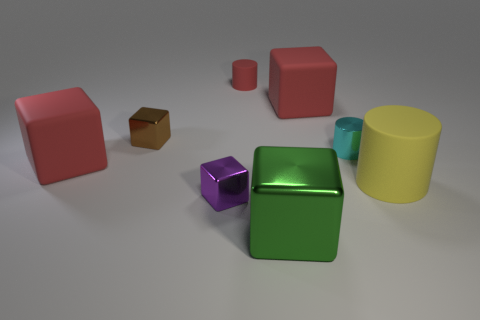The red rubber cylinder has what size?
Your response must be concise. Small. There is a big red cube that is on the right side of the red matte block that is to the left of the tiny purple metallic thing; how many tiny objects are right of it?
Your response must be concise. 1. There is a rubber object in front of the rubber cube on the left side of the tiny red object; what is its shape?
Make the answer very short. Cylinder. The green metallic thing that is the same shape as the brown shiny object is what size?
Ensure brevity in your answer.  Large. Is there any other thing that has the same size as the green metal object?
Offer a very short reply. Yes. There is a cylinder in front of the cyan shiny cylinder; what is its color?
Make the answer very short. Yellow. The small object that is right of the big block that is behind the red rubber block left of the purple metal cube is made of what material?
Your answer should be compact. Metal. There is a red rubber cube that is to the right of the matte cylinder behind the yellow cylinder; what is its size?
Keep it short and to the point. Large. There is another tiny shiny object that is the same shape as the brown shiny object; what is its color?
Ensure brevity in your answer.  Purple. How many other big cylinders have the same color as the metal cylinder?
Make the answer very short. 0. 